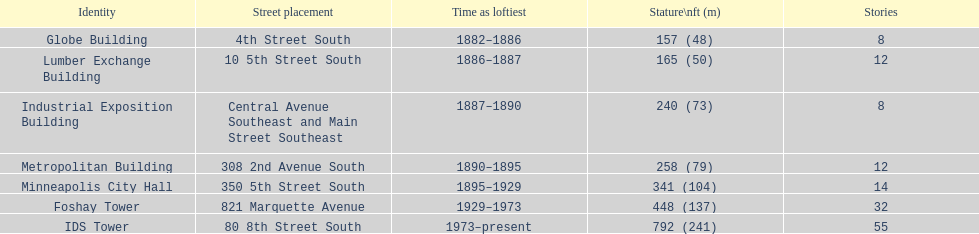How many floors does the foshay tower have? 32. 